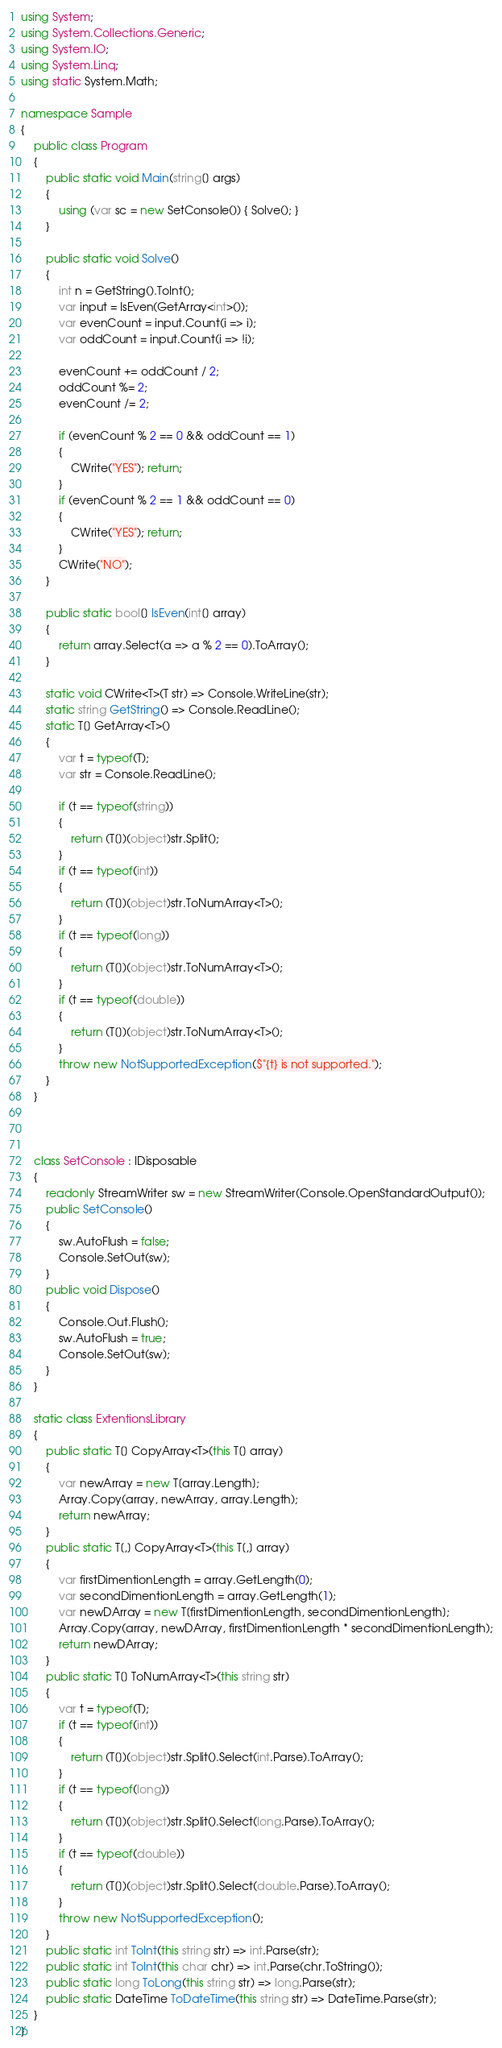Convert code to text. <code><loc_0><loc_0><loc_500><loc_500><_C#_>using System;
using System.Collections.Generic;
using System.IO;
using System.Linq;
using static System.Math;

namespace Sample
{
    public class Program
    {
        public static void Main(string[] args)
        {
            using (var sc = new SetConsole()) { Solve(); }
        }

        public static void Solve()
        {
            int n = GetString().ToInt();
            var input = IsEven(GetArray<int>());
            var evenCount = input.Count(i => i);
            var oddCount = input.Count(i => !i);

            evenCount += oddCount / 2;
            oddCount %= 2;
            evenCount /= 2;

            if (evenCount % 2 == 0 && oddCount == 1)
            {
                CWrite("YES"); return;
            }
            if (evenCount % 2 == 1 && oddCount == 0)
            {
                CWrite("YES"); return;
            }
            CWrite("NO");
        }

        public static bool[] IsEven(int[] array)
        {
            return array.Select(a => a % 2 == 0).ToArray();
        }

        static void CWrite<T>(T str) => Console.WriteLine(str);
        static string GetString() => Console.ReadLine();
        static T[] GetArray<T>()
        {
            var t = typeof(T);
            var str = Console.ReadLine();

            if (t == typeof(string))
            {
                return (T[])(object)str.Split();
            }
            if (t == typeof(int))
            {
                return (T[])(object)str.ToNumArray<T>();
            }
            if (t == typeof(long))
            {
                return (T[])(object)str.ToNumArray<T>();
            }
            if (t == typeof(double))
            {
                return (T[])(object)str.ToNumArray<T>();
            }
            throw new NotSupportedException($"{t} is not supported.");
        }
    }



    class SetConsole : IDisposable
    {
        readonly StreamWriter sw = new StreamWriter(Console.OpenStandardOutput());
        public SetConsole()
        {
            sw.AutoFlush = false;
            Console.SetOut(sw);
        }
        public void Dispose()
        {
            Console.Out.Flush();
            sw.AutoFlush = true;
            Console.SetOut(sw);
        }
    }

    static class ExtentionsLibrary
    {
        public static T[] CopyArray<T>(this T[] array)
        {
            var newArray = new T[array.Length];
            Array.Copy(array, newArray, array.Length);
            return newArray;
        }
        public static T[,] CopyArray<T>(this T[,] array)
        {
            var firstDimentionLength = array.GetLength(0);
            var secondDimentionLength = array.GetLength(1);
            var newDArray = new T[firstDimentionLength, secondDimentionLength];
            Array.Copy(array, newDArray, firstDimentionLength * secondDimentionLength);
            return newDArray;
        }
        public static T[] ToNumArray<T>(this string str)
        {
            var t = typeof(T);
            if (t == typeof(int))
            {
                return (T[])(object)str.Split().Select(int.Parse).ToArray();
            }
            if (t == typeof(long))
            {
                return (T[])(object)str.Split().Select(long.Parse).ToArray();
            }
            if (t == typeof(double))
            {
                return (T[])(object)str.Split().Select(double.Parse).ToArray();
            }
            throw new NotSupportedException();
        }
        public static int ToInt(this string str) => int.Parse(str);
        public static int ToInt(this char chr) => int.Parse(chr.ToString());
        public static long ToLong(this string str) => long.Parse(str);
        public static DateTime ToDateTime(this string str) => DateTime.Parse(str);
    }
}
</code> 